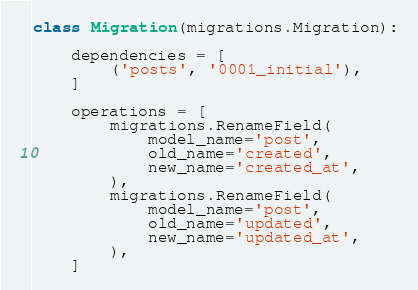Convert code to text. <code><loc_0><loc_0><loc_500><loc_500><_Python_>

class Migration(migrations.Migration):

    dependencies = [
        ('posts', '0001_initial'),
    ]

    operations = [
        migrations.RenameField(
            model_name='post',
            old_name='created',
            new_name='created_at',
        ),
        migrations.RenameField(
            model_name='post',
            old_name='updated',
            new_name='updated_at',
        ),
    ]
</code> 